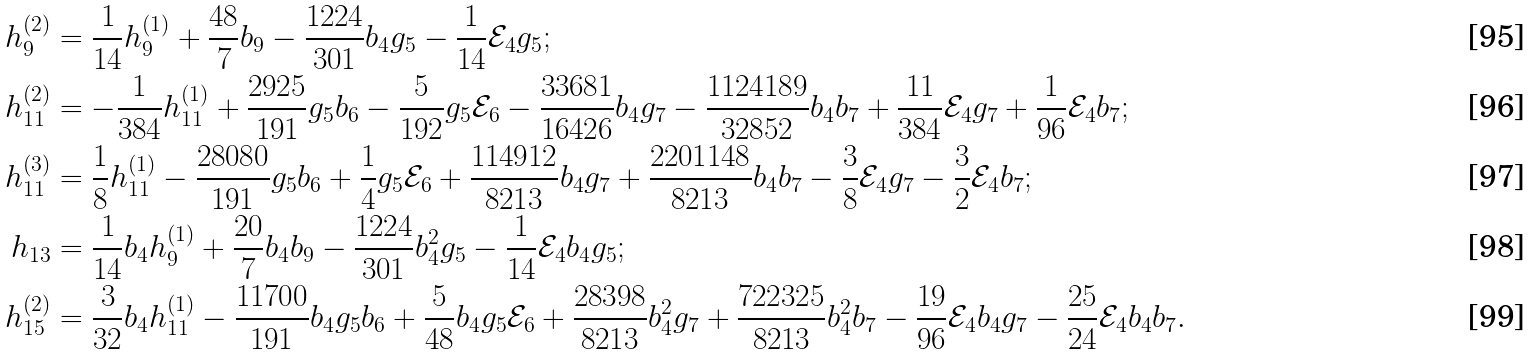Convert formula to latex. <formula><loc_0><loc_0><loc_500><loc_500>h _ { 9 } ^ { ( 2 ) } & = \frac { 1 } { 1 4 } h _ { 9 } ^ { ( 1 ) } + \frac { 4 8 } { 7 } b _ { 9 } - \frac { 1 2 2 4 } { 3 0 1 } b _ { 4 } g _ { 5 } - \frac { 1 } { 1 4 } \mathcal { E } _ { 4 } g _ { 5 } ; \\ h _ { 1 1 } ^ { ( 2 ) } & = - \frac { 1 } { 3 8 4 } h _ { 1 1 } ^ { ( 1 ) } + \frac { 2 9 2 5 } { 1 9 1 } g _ { 5 } b _ { 6 } - \frac { 5 } { 1 9 2 } g _ { 5 } \mathcal { E } _ { 6 } - \frac { 3 3 6 8 1 } { 1 6 4 2 6 } b _ { 4 } g _ { 7 } - \frac { 1 1 2 4 1 8 9 } { 3 2 8 5 2 } b _ { 4 } b _ { 7 } + \frac { 1 1 } { 3 8 4 } \mathcal { E } _ { 4 } g _ { 7 } + \frac { 1 } { 9 6 } \mathcal { E } _ { 4 } b _ { 7 } ; \\ h _ { 1 1 } ^ { ( 3 ) } & = \frac { 1 } { 8 } h _ { 1 1 } ^ { ( 1 ) } - \frac { 2 8 0 8 0 } { 1 9 1 } g _ { 5 } b _ { 6 } + \frac { 1 } { 4 } g _ { 5 } \mathcal { E } _ { 6 } + \frac { 1 1 4 9 1 2 } { 8 2 1 3 } b _ { 4 } g _ { 7 } + \frac { 2 2 0 1 1 4 8 } { 8 2 1 3 } b _ { 4 } b _ { 7 } - \frac { 3 } { 8 } \mathcal { E } _ { 4 } g _ { 7 } - \frac { 3 } { 2 } \mathcal { E } _ { 4 } b _ { 7 } ; \\ h _ { 1 3 } & = \frac { 1 } { 1 4 } b _ { 4 } h _ { 9 } ^ { ( 1 ) } + \frac { 2 0 } { 7 } b _ { 4 } b _ { 9 } - \frac { 1 2 2 4 } { 3 0 1 } b _ { 4 } ^ { 2 } g _ { 5 } - \frac { 1 } { 1 4 } \mathcal { E } _ { 4 } b _ { 4 } g _ { 5 } ; \\ h _ { 1 5 } ^ { ( 2 ) } & = \frac { 3 } { 3 2 } b _ { 4 } h _ { 1 1 } ^ { ( 1 ) } - \frac { 1 1 7 0 0 } { 1 9 1 } b _ { 4 } g _ { 5 } b _ { 6 } + \frac { 5 } { 4 8 } b _ { 4 } g _ { 5 } \mathcal { E } _ { 6 } + \frac { 2 8 3 9 8 } { 8 2 1 3 } b _ { 4 } ^ { 2 } g _ { 7 } + \frac { 7 2 2 3 2 5 } { 8 2 1 3 } b _ { 4 } ^ { 2 } b _ { 7 } - \frac { 1 9 } { 9 6 } \mathcal { E } _ { 4 } b _ { 4 } g _ { 7 } - \frac { 2 5 } { 2 4 } \mathcal { E } _ { 4 } b _ { 4 } b _ { 7 } .</formula> 